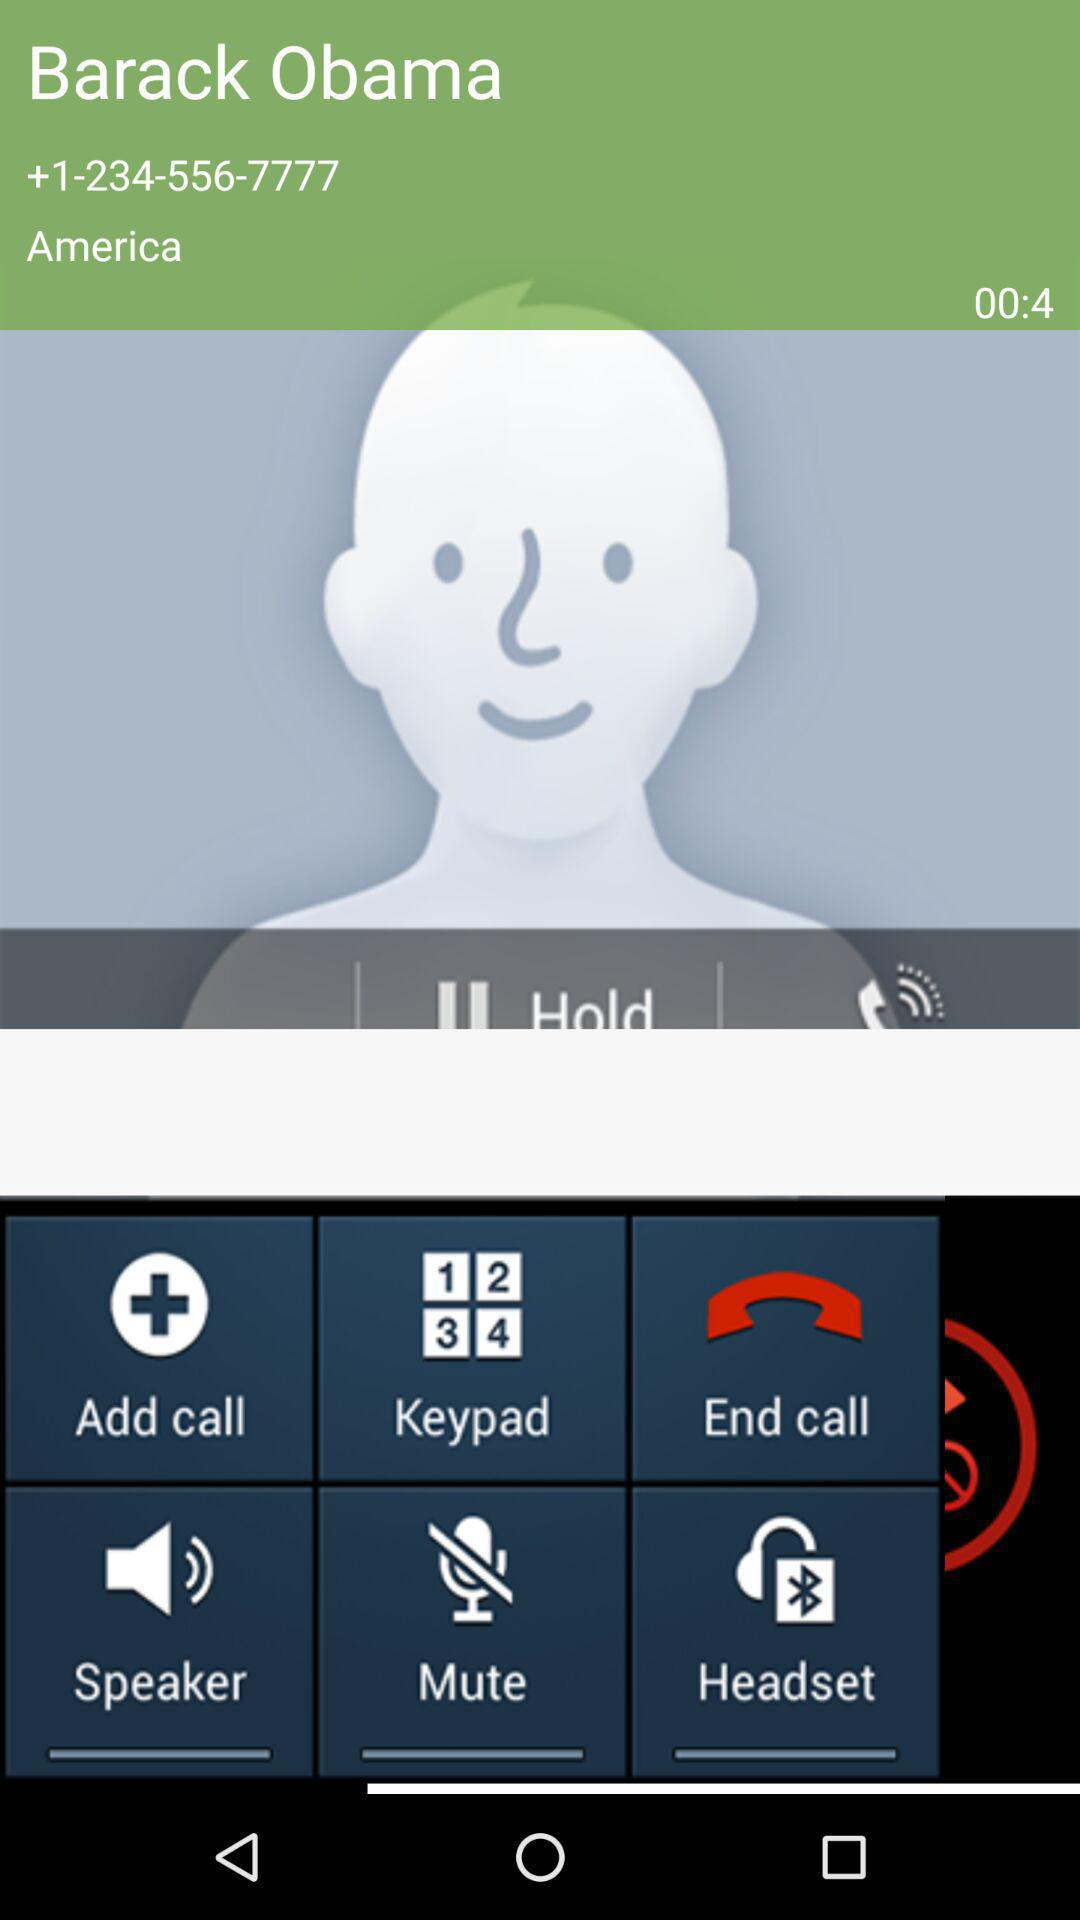What is the contact number of Barack Obama? The contact number of Barack Obama is +1-234-556-7777. 